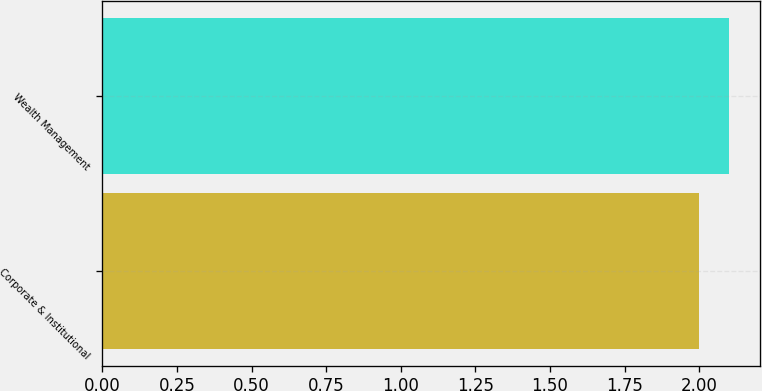<chart> <loc_0><loc_0><loc_500><loc_500><bar_chart><fcel>Corporate & Institutional<fcel>Wealth Management<nl><fcel>2<fcel>2.1<nl></chart> 